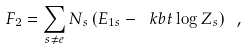Convert formula to latex. <formula><loc_0><loc_0><loc_500><loc_500>F _ { 2 } = \sum _ { s \neq e } N _ { s } \left ( E _ { 1 s } - \ k b t \log Z _ { s } \right ) \ ,</formula> 